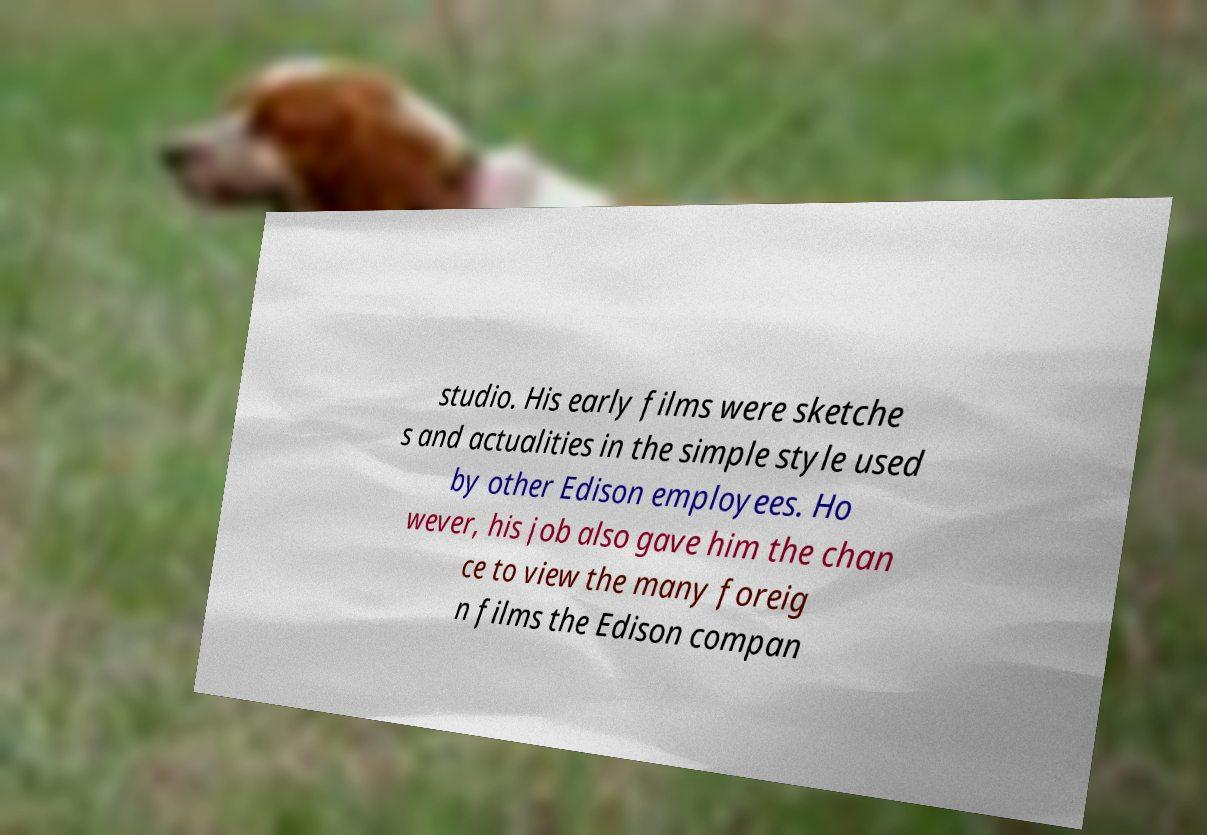Please identify and transcribe the text found in this image. studio. His early films were sketche s and actualities in the simple style used by other Edison employees. Ho wever, his job also gave him the chan ce to view the many foreig n films the Edison compan 